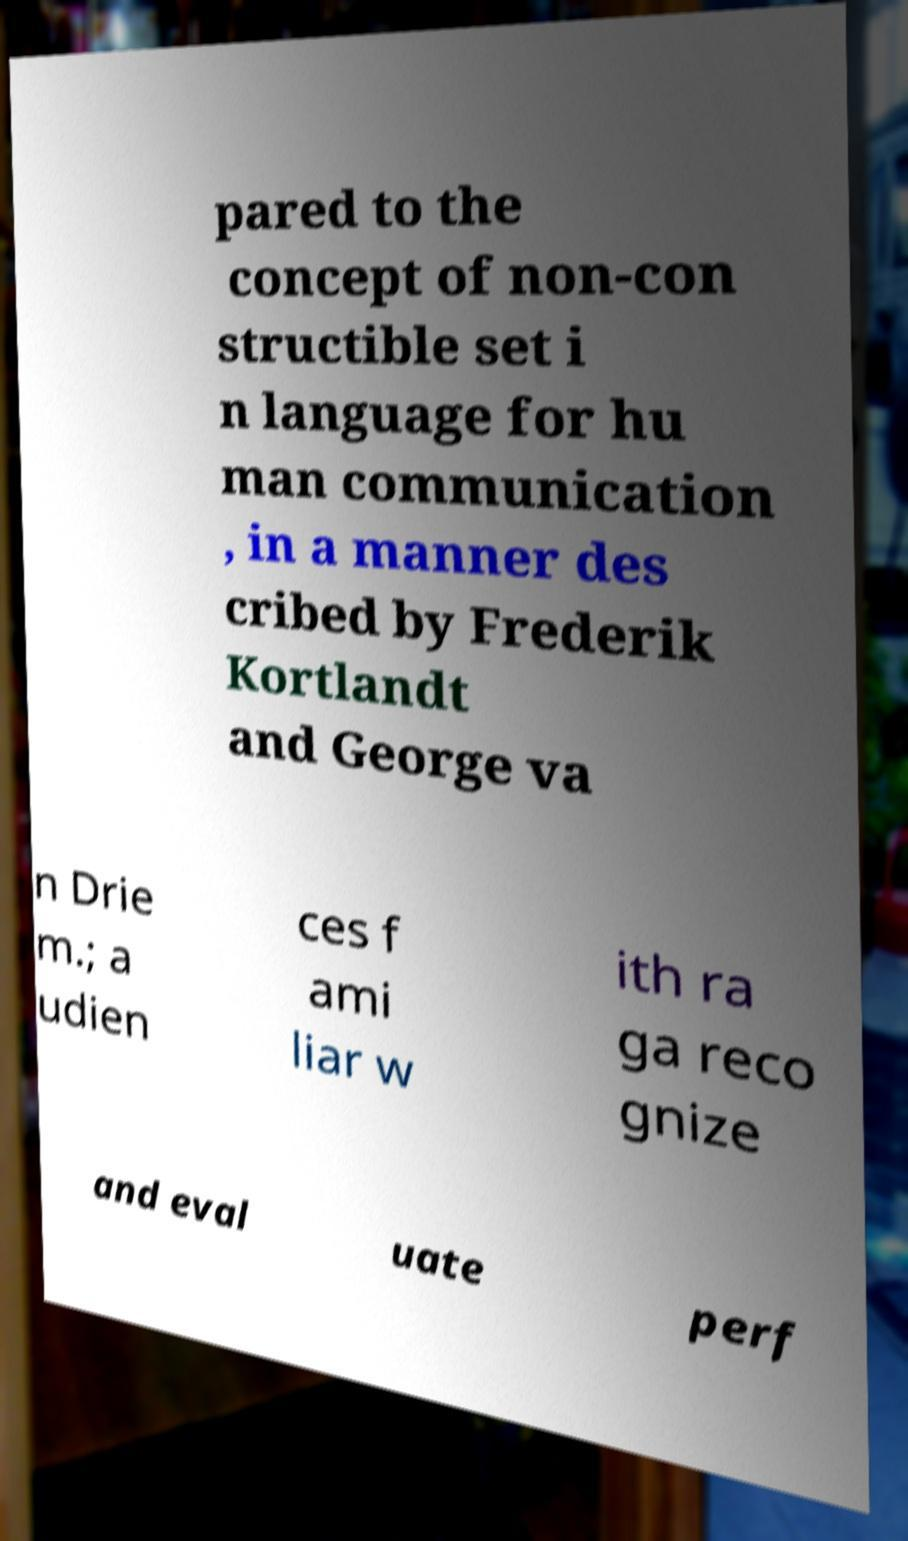Could you extract and type out the text from this image? pared to the concept of non-con structible set i n language for hu man communication , in a manner des cribed by Frederik Kortlandt and George va n Drie m.; a udien ces f ami liar w ith ra ga reco gnize and eval uate perf 